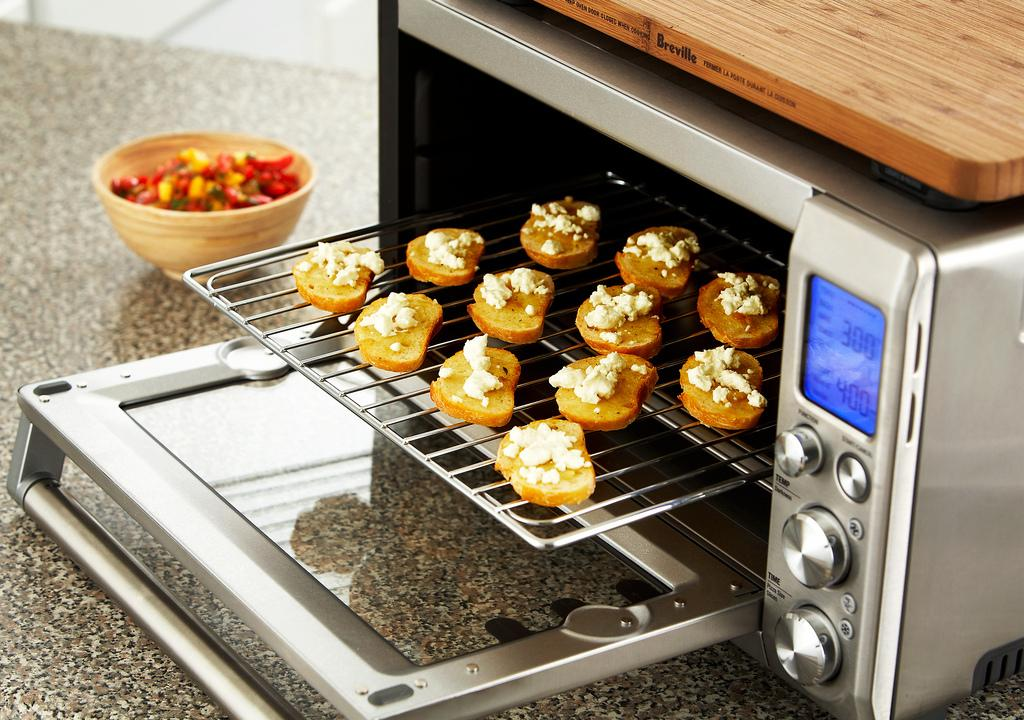<image>
Summarize the visual content of the image. 300 to 400 degrees is what this mini oven is set at. 